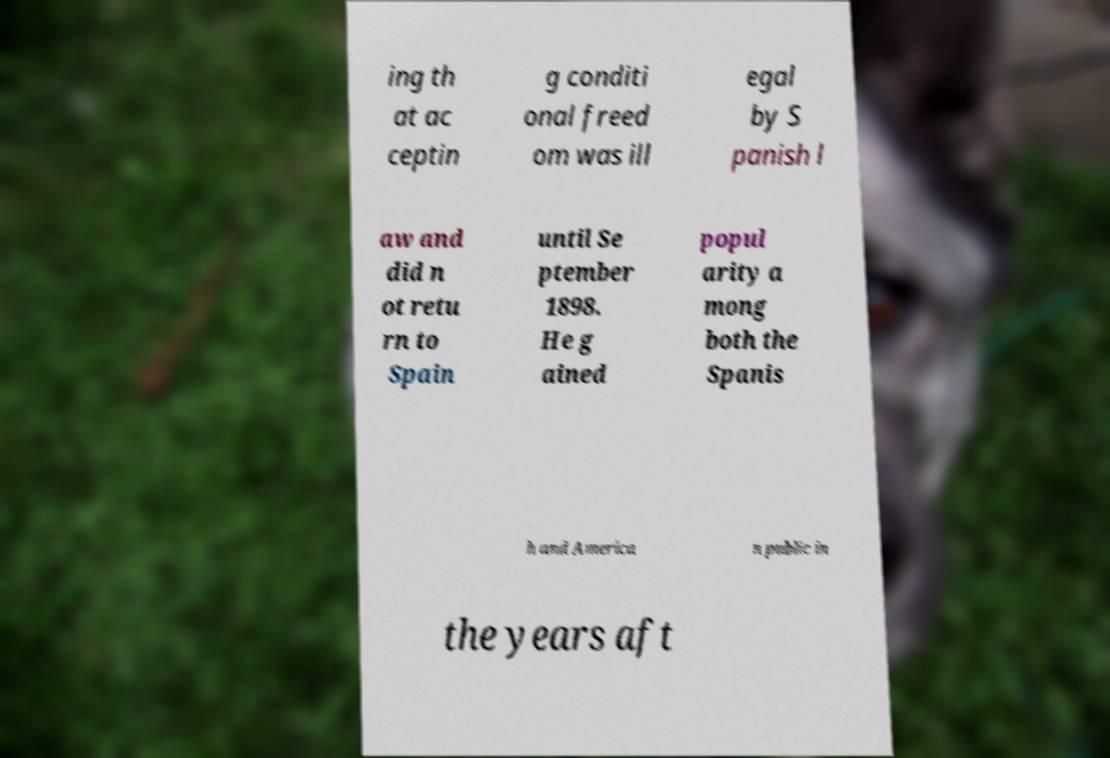Please identify and transcribe the text found in this image. ing th at ac ceptin g conditi onal freed om was ill egal by S panish l aw and did n ot retu rn to Spain until Se ptember 1898. He g ained popul arity a mong both the Spanis h and America n public in the years aft 